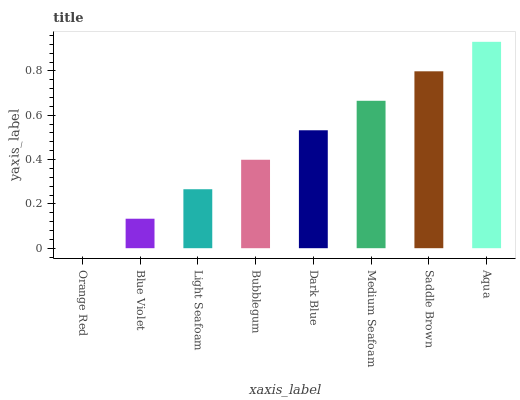Is Orange Red the minimum?
Answer yes or no. Yes. Is Aqua the maximum?
Answer yes or no. Yes. Is Blue Violet the minimum?
Answer yes or no. No. Is Blue Violet the maximum?
Answer yes or no. No. Is Blue Violet greater than Orange Red?
Answer yes or no. Yes. Is Orange Red less than Blue Violet?
Answer yes or no. Yes. Is Orange Red greater than Blue Violet?
Answer yes or no. No. Is Blue Violet less than Orange Red?
Answer yes or no. No. Is Dark Blue the high median?
Answer yes or no. Yes. Is Bubblegum the low median?
Answer yes or no. Yes. Is Saddle Brown the high median?
Answer yes or no. No. Is Medium Seafoam the low median?
Answer yes or no. No. 